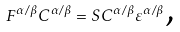Convert formula to latex. <formula><loc_0><loc_0><loc_500><loc_500>F ^ { \alpha / \beta } C ^ { \alpha / \beta } = S C ^ { \alpha / \beta } \varepsilon ^ { \alpha / \beta } \text {,}</formula> 